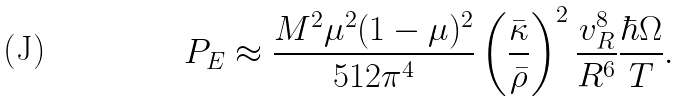Convert formula to latex. <formula><loc_0><loc_0><loc_500><loc_500>& P _ { E } \approx \frac { M ^ { 2 } \mu ^ { 2 } ( 1 - \mu ) ^ { 2 } } { 5 1 2 \pi ^ { 4 } } \left ( \frac { \bar { \kappa } } { \bar { \rho } } \right ) ^ { 2 } \frac { v _ { R } ^ { 8 } } { R ^ { 6 } } \frac { \hbar { \Omega } } { T } .</formula> 